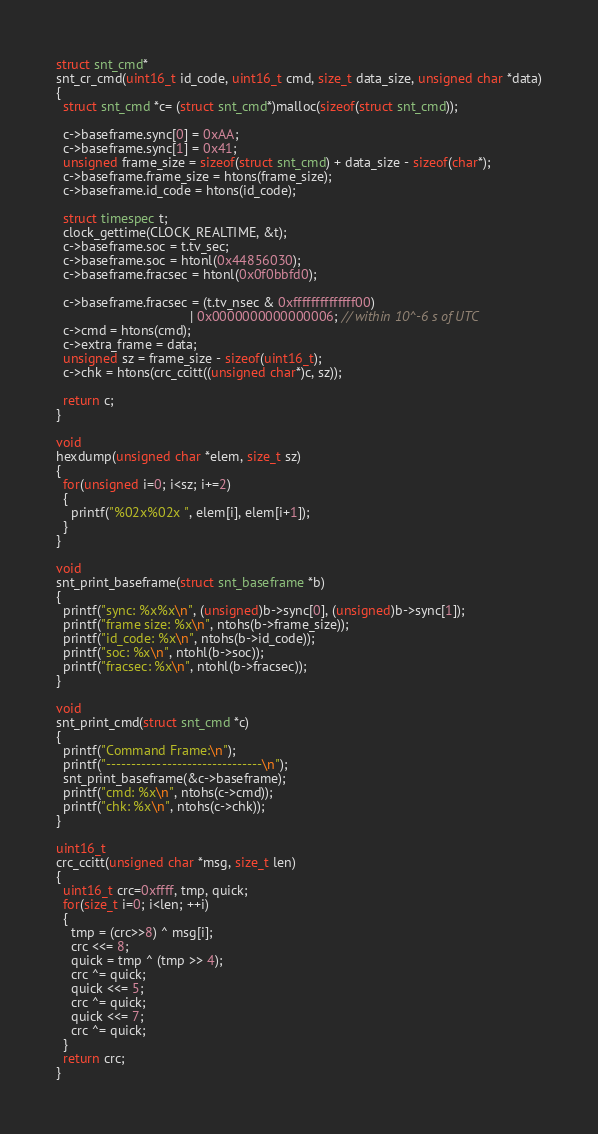<code> <loc_0><loc_0><loc_500><loc_500><_C_>struct snt_cmd* 
snt_cr_cmd(uint16_t id_code, uint16_t cmd, size_t data_size, unsigned char *data)
{
  struct snt_cmd *c= (struct snt_cmd*)malloc(sizeof(struct snt_cmd));

  c->baseframe.sync[0] = 0xAA;
  c->baseframe.sync[1] = 0x41;
  unsigned frame_size = sizeof(struct snt_cmd) + data_size - sizeof(char*); 
  c->baseframe.frame_size = htons(frame_size);
  c->baseframe.id_code = htons(id_code);

  struct timespec t;
  clock_gettime(CLOCK_REALTIME, &t);
  c->baseframe.soc = t.tv_sec;
  c->baseframe.soc = htonl(0x44856030);
  c->baseframe.fracsec = htonl(0x0f0bbfd0);

  c->baseframe.fracsec = (t.tv_nsec & 0xffffffffffffff00)
                                    | 0x0000000000000006; // within 10^-6 s of UTC
  c->cmd = htons(cmd);
  c->extra_frame = data;
  unsigned sz = frame_size - sizeof(uint16_t);
  c->chk = htons(crc_ccitt((unsigned char*)c, sz));
  
  return c;
}

void
hexdump(unsigned char *elem, size_t sz)
{
  for(unsigned i=0; i<sz; i+=2)
  {
    printf("%02x%02x ", elem[i], elem[i+1]);
  }
}

void
snt_print_baseframe(struct snt_baseframe *b)
{
  printf("sync: %x%x\n", (unsigned)b->sync[0], (unsigned)b->sync[1]);
  printf("frame size: %x\n", ntohs(b->frame_size));
  printf("id_code: %x\n", ntohs(b->id_code));
  printf("soc: %x\n", ntohl(b->soc));
  printf("fracsec: %x\n", ntohl(b->fracsec));
}

void
snt_print_cmd(struct snt_cmd *c)
{
  printf("Command Frame:\n");
  printf("-------------------------------\n");
  snt_print_baseframe(&c->baseframe);
  printf("cmd: %x\n", ntohs(c->cmd));
  printf("chk: %x\n", ntohs(c->chk));
}

uint16_t 
crc_ccitt(unsigned char *msg, size_t len)
{
  uint16_t crc=0xffff, tmp, quick;
  for(size_t i=0; i<len; ++i)
  {
    tmp = (crc>>8) ^ msg[i];
    crc <<= 8;
    quick = tmp ^ (tmp >> 4);
    crc ^= quick;
    quick <<= 5;
    crc ^= quick;
    quick <<= 7;
    crc ^= quick;
  }
  return crc;
}
</code> 